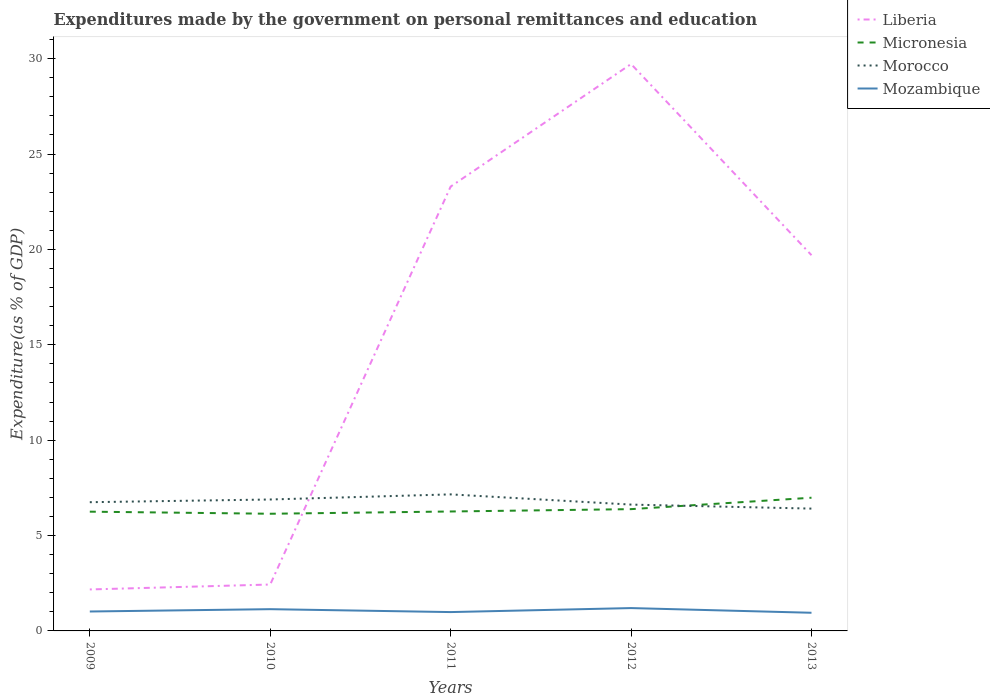Across all years, what is the maximum expenditures made by the government on personal remittances and education in Morocco?
Your answer should be compact. 6.41. In which year was the expenditures made by the government on personal remittances and education in Mozambique maximum?
Your response must be concise. 2013. What is the total expenditures made by the government on personal remittances and education in Micronesia in the graph?
Your answer should be compact. -0.73. What is the difference between the highest and the second highest expenditures made by the government on personal remittances and education in Mozambique?
Your answer should be compact. 0.25. What is the difference between the highest and the lowest expenditures made by the government on personal remittances and education in Morocco?
Give a very brief answer. 2. Does the graph contain any zero values?
Provide a succinct answer. No. Where does the legend appear in the graph?
Offer a very short reply. Top right. What is the title of the graph?
Give a very brief answer. Expenditures made by the government on personal remittances and education. What is the label or title of the X-axis?
Give a very brief answer. Years. What is the label or title of the Y-axis?
Your response must be concise. Expenditure(as % of GDP). What is the Expenditure(as % of GDP) in Liberia in 2009?
Your answer should be very brief. 2.17. What is the Expenditure(as % of GDP) of Micronesia in 2009?
Give a very brief answer. 6.25. What is the Expenditure(as % of GDP) in Morocco in 2009?
Provide a succinct answer. 6.75. What is the Expenditure(as % of GDP) of Mozambique in 2009?
Give a very brief answer. 1.02. What is the Expenditure(as % of GDP) of Liberia in 2010?
Your answer should be very brief. 2.43. What is the Expenditure(as % of GDP) in Micronesia in 2010?
Keep it short and to the point. 6.14. What is the Expenditure(as % of GDP) of Morocco in 2010?
Keep it short and to the point. 6.89. What is the Expenditure(as % of GDP) of Mozambique in 2010?
Offer a very short reply. 1.14. What is the Expenditure(as % of GDP) in Liberia in 2011?
Your answer should be compact. 23.29. What is the Expenditure(as % of GDP) of Micronesia in 2011?
Provide a short and direct response. 6.26. What is the Expenditure(as % of GDP) of Morocco in 2011?
Make the answer very short. 7.16. What is the Expenditure(as % of GDP) in Mozambique in 2011?
Ensure brevity in your answer.  0.99. What is the Expenditure(as % of GDP) of Liberia in 2012?
Your response must be concise. 29.72. What is the Expenditure(as % of GDP) of Micronesia in 2012?
Offer a terse response. 6.38. What is the Expenditure(as % of GDP) in Morocco in 2012?
Provide a short and direct response. 6.62. What is the Expenditure(as % of GDP) in Mozambique in 2012?
Offer a very short reply. 1.2. What is the Expenditure(as % of GDP) of Liberia in 2013?
Keep it short and to the point. 19.7. What is the Expenditure(as % of GDP) of Micronesia in 2013?
Offer a very short reply. 6.98. What is the Expenditure(as % of GDP) in Morocco in 2013?
Offer a very short reply. 6.41. What is the Expenditure(as % of GDP) of Mozambique in 2013?
Make the answer very short. 0.95. Across all years, what is the maximum Expenditure(as % of GDP) in Liberia?
Provide a succinct answer. 29.72. Across all years, what is the maximum Expenditure(as % of GDP) of Micronesia?
Ensure brevity in your answer.  6.98. Across all years, what is the maximum Expenditure(as % of GDP) of Morocco?
Offer a very short reply. 7.16. Across all years, what is the maximum Expenditure(as % of GDP) in Mozambique?
Your response must be concise. 1.2. Across all years, what is the minimum Expenditure(as % of GDP) of Liberia?
Offer a terse response. 2.17. Across all years, what is the minimum Expenditure(as % of GDP) of Micronesia?
Your response must be concise. 6.14. Across all years, what is the minimum Expenditure(as % of GDP) of Morocco?
Provide a succinct answer. 6.41. Across all years, what is the minimum Expenditure(as % of GDP) in Mozambique?
Your answer should be compact. 0.95. What is the total Expenditure(as % of GDP) in Liberia in the graph?
Your response must be concise. 77.32. What is the total Expenditure(as % of GDP) in Micronesia in the graph?
Provide a short and direct response. 32.02. What is the total Expenditure(as % of GDP) of Morocco in the graph?
Offer a terse response. 33.83. What is the total Expenditure(as % of GDP) in Mozambique in the graph?
Provide a succinct answer. 5.3. What is the difference between the Expenditure(as % of GDP) of Liberia in 2009 and that in 2010?
Offer a very short reply. -0.26. What is the difference between the Expenditure(as % of GDP) in Micronesia in 2009 and that in 2010?
Ensure brevity in your answer.  0.11. What is the difference between the Expenditure(as % of GDP) in Morocco in 2009 and that in 2010?
Give a very brief answer. -0.14. What is the difference between the Expenditure(as % of GDP) in Mozambique in 2009 and that in 2010?
Give a very brief answer. -0.12. What is the difference between the Expenditure(as % of GDP) in Liberia in 2009 and that in 2011?
Your response must be concise. -21.12. What is the difference between the Expenditure(as % of GDP) of Micronesia in 2009 and that in 2011?
Make the answer very short. -0.01. What is the difference between the Expenditure(as % of GDP) of Morocco in 2009 and that in 2011?
Give a very brief answer. -0.41. What is the difference between the Expenditure(as % of GDP) in Mozambique in 2009 and that in 2011?
Give a very brief answer. 0.03. What is the difference between the Expenditure(as % of GDP) in Liberia in 2009 and that in 2012?
Your answer should be compact. -27.55. What is the difference between the Expenditure(as % of GDP) in Micronesia in 2009 and that in 2012?
Offer a terse response. -0.13. What is the difference between the Expenditure(as % of GDP) of Morocco in 2009 and that in 2012?
Make the answer very short. 0.13. What is the difference between the Expenditure(as % of GDP) in Mozambique in 2009 and that in 2012?
Ensure brevity in your answer.  -0.18. What is the difference between the Expenditure(as % of GDP) in Liberia in 2009 and that in 2013?
Give a very brief answer. -17.52. What is the difference between the Expenditure(as % of GDP) of Micronesia in 2009 and that in 2013?
Keep it short and to the point. -0.73. What is the difference between the Expenditure(as % of GDP) in Morocco in 2009 and that in 2013?
Your answer should be compact. 0.34. What is the difference between the Expenditure(as % of GDP) of Mozambique in 2009 and that in 2013?
Your response must be concise. 0.07. What is the difference between the Expenditure(as % of GDP) of Liberia in 2010 and that in 2011?
Provide a succinct answer. -20.86. What is the difference between the Expenditure(as % of GDP) in Micronesia in 2010 and that in 2011?
Your answer should be very brief. -0.12. What is the difference between the Expenditure(as % of GDP) in Morocco in 2010 and that in 2011?
Offer a terse response. -0.27. What is the difference between the Expenditure(as % of GDP) in Mozambique in 2010 and that in 2011?
Offer a very short reply. 0.15. What is the difference between the Expenditure(as % of GDP) of Liberia in 2010 and that in 2012?
Provide a succinct answer. -27.29. What is the difference between the Expenditure(as % of GDP) in Micronesia in 2010 and that in 2012?
Offer a terse response. -0.24. What is the difference between the Expenditure(as % of GDP) in Morocco in 2010 and that in 2012?
Give a very brief answer. 0.27. What is the difference between the Expenditure(as % of GDP) in Mozambique in 2010 and that in 2012?
Keep it short and to the point. -0.06. What is the difference between the Expenditure(as % of GDP) in Liberia in 2010 and that in 2013?
Your answer should be compact. -17.27. What is the difference between the Expenditure(as % of GDP) of Micronesia in 2010 and that in 2013?
Your response must be concise. -0.84. What is the difference between the Expenditure(as % of GDP) of Morocco in 2010 and that in 2013?
Give a very brief answer. 0.48. What is the difference between the Expenditure(as % of GDP) in Mozambique in 2010 and that in 2013?
Your answer should be compact. 0.19. What is the difference between the Expenditure(as % of GDP) in Liberia in 2011 and that in 2012?
Your answer should be compact. -6.43. What is the difference between the Expenditure(as % of GDP) in Micronesia in 2011 and that in 2012?
Offer a very short reply. -0.12. What is the difference between the Expenditure(as % of GDP) in Morocco in 2011 and that in 2012?
Offer a very short reply. 0.54. What is the difference between the Expenditure(as % of GDP) in Mozambique in 2011 and that in 2012?
Keep it short and to the point. -0.21. What is the difference between the Expenditure(as % of GDP) of Liberia in 2011 and that in 2013?
Offer a terse response. 3.6. What is the difference between the Expenditure(as % of GDP) of Micronesia in 2011 and that in 2013?
Your response must be concise. -0.72. What is the difference between the Expenditure(as % of GDP) of Morocco in 2011 and that in 2013?
Ensure brevity in your answer.  0.75. What is the difference between the Expenditure(as % of GDP) of Mozambique in 2011 and that in 2013?
Offer a very short reply. 0.04. What is the difference between the Expenditure(as % of GDP) of Liberia in 2012 and that in 2013?
Offer a very short reply. 10.02. What is the difference between the Expenditure(as % of GDP) in Micronesia in 2012 and that in 2013?
Your answer should be very brief. -0.6. What is the difference between the Expenditure(as % of GDP) of Morocco in 2012 and that in 2013?
Your response must be concise. 0.21. What is the difference between the Expenditure(as % of GDP) of Mozambique in 2012 and that in 2013?
Offer a very short reply. 0.25. What is the difference between the Expenditure(as % of GDP) in Liberia in 2009 and the Expenditure(as % of GDP) in Micronesia in 2010?
Offer a terse response. -3.97. What is the difference between the Expenditure(as % of GDP) in Liberia in 2009 and the Expenditure(as % of GDP) in Morocco in 2010?
Give a very brief answer. -4.72. What is the difference between the Expenditure(as % of GDP) in Liberia in 2009 and the Expenditure(as % of GDP) in Mozambique in 2010?
Offer a terse response. 1.03. What is the difference between the Expenditure(as % of GDP) of Micronesia in 2009 and the Expenditure(as % of GDP) of Morocco in 2010?
Provide a short and direct response. -0.64. What is the difference between the Expenditure(as % of GDP) of Micronesia in 2009 and the Expenditure(as % of GDP) of Mozambique in 2010?
Keep it short and to the point. 5.11. What is the difference between the Expenditure(as % of GDP) in Morocco in 2009 and the Expenditure(as % of GDP) in Mozambique in 2010?
Your answer should be very brief. 5.61. What is the difference between the Expenditure(as % of GDP) in Liberia in 2009 and the Expenditure(as % of GDP) in Micronesia in 2011?
Ensure brevity in your answer.  -4.09. What is the difference between the Expenditure(as % of GDP) in Liberia in 2009 and the Expenditure(as % of GDP) in Morocco in 2011?
Offer a very short reply. -4.98. What is the difference between the Expenditure(as % of GDP) of Liberia in 2009 and the Expenditure(as % of GDP) of Mozambique in 2011?
Ensure brevity in your answer.  1.19. What is the difference between the Expenditure(as % of GDP) in Micronesia in 2009 and the Expenditure(as % of GDP) in Morocco in 2011?
Provide a succinct answer. -0.91. What is the difference between the Expenditure(as % of GDP) in Micronesia in 2009 and the Expenditure(as % of GDP) in Mozambique in 2011?
Your response must be concise. 5.26. What is the difference between the Expenditure(as % of GDP) of Morocco in 2009 and the Expenditure(as % of GDP) of Mozambique in 2011?
Offer a very short reply. 5.76. What is the difference between the Expenditure(as % of GDP) in Liberia in 2009 and the Expenditure(as % of GDP) in Micronesia in 2012?
Offer a terse response. -4.21. What is the difference between the Expenditure(as % of GDP) of Liberia in 2009 and the Expenditure(as % of GDP) of Morocco in 2012?
Keep it short and to the point. -4.45. What is the difference between the Expenditure(as % of GDP) of Liberia in 2009 and the Expenditure(as % of GDP) of Mozambique in 2012?
Your answer should be very brief. 0.98. What is the difference between the Expenditure(as % of GDP) in Micronesia in 2009 and the Expenditure(as % of GDP) in Morocco in 2012?
Keep it short and to the point. -0.37. What is the difference between the Expenditure(as % of GDP) of Micronesia in 2009 and the Expenditure(as % of GDP) of Mozambique in 2012?
Offer a very short reply. 5.05. What is the difference between the Expenditure(as % of GDP) of Morocco in 2009 and the Expenditure(as % of GDP) of Mozambique in 2012?
Your response must be concise. 5.55. What is the difference between the Expenditure(as % of GDP) of Liberia in 2009 and the Expenditure(as % of GDP) of Micronesia in 2013?
Your answer should be very brief. -4.81. What is the difference between the Expenditure(as % of GDP) of Liberia in 2009 and the Expenditure(as % of GDP) of Morocco in 2013?
Keep it short and to the point. -4.24. What is the difference between the Expenditure(as % of GDP) of Liberia in 2009 and the Expenditure(as % of GDP) of Mozambique in 2013?
Make the answer very short. 1.22. What is the difference between the Expenditure(as % of GDP) in Micronesia in 2009 and the Expenditure(as % of GDP) in Morocco in 2013?
Your answer should be compact. -0.16. What is the difference between the Expenditure(as % of GDP) in Micronesia in 2009 and the Expenditure(as % of GDP) in Mozambique in 2013?
Provide a short and direct response. 5.3. What is the difference between the Expenditure(as % of GDP) of Morocco in 2009 and the Expenditure(as % of GDP) of Mozambique in 2013?
Make the answer very short. 5.8. What is the difference between the Expenditure(as % of GDP) in Liberia in 2010 and the Expenditure(as % of GDP) in Micronesia in 2011?
Your answer should be very brief. -3.83. What is the difference between the Expenditure(as % of GDP) of Liberia in 2010 and the Expenditure(as % of GDP) of Morocco in 2011?
Your response must be concise. -4.73. What is the difference between the Expenditure(as % of GDP) of Liberia in 2010 and the Expenditure(as % of GDP) of Mozambique in 2011?
Provide a succinct answer. 1.44. What is the difference between the Expenditure(as % of GDP) in Micronesia in 2010 and the Expenditure(as % of GDP) in Morocco in 2011?
Provide a succinct answer. -1.02. What is the difference between the Expenditure(as % of GDP) of Micronesia in 2010 and the Expenditure(as % of GDP) of Mozambique in 2011?
Your answer should be very brief. 5.16. What is the difference between the Expenditure(as % of GDP) in Morocco in 2010 and the Expenditure(as % of GDP) in Mozambique in 2011?
Offer a very short reply. 5.9. What is the difference between the Expenditure(as % of GDP) of Liberia in 2010 and the Expenditure(as % of GDP) of Micronesia in 2012?
Provide a succinct answer. -3.95. What is the difference between the Expenditure(as % of GDP) in Liberia in 2010 and the Expenditure(as % of GDP) in Morocco in 2012?
Keep it short and to the point. -4.19. What is the difference between the Expenditure(as % of GDP) of Liberia in 2010 and the Expenditure(as % of GDP) of Mozambique in 2012?
Provide a succinct answer. 1.23. What is the difference between the Expenditure(as % of GDP) of Micronesia in 2010 and the Expenditure(as % of GDP) of Morocco in 2012?
Give a very brief answer. -0.48. What is the difference between the Expenditure(as % of GDP) of Micronesia in 2010 and the Expenditure(as % of GDP) of Mozambique in 2012?
Your answer should be compact. 4.94. What is the difference between the Expenditure(as % of GDP) of Morocco in 2010 and the Expenditure(as % of GDP) of Mozambique in 2012?
Your response must be concise. 5.69. What is the difference between the Expenditure(as % of GDP) of Liberia in 2010 and the Expenditure(as % of GDP) of Micronesia in 2013?
Provide a short and direct response. -4.55. What is the difference between the Expenditure(as % of GDP) in Liberia in 2010 and the Expenditure(as % of GDP) in Morocco in 2013?
Provide a succinct answer. -3.98. What is the difference between the Expenditure(as % of GDP) in Liberia in 2010 and the Expenditure(as % of GDP) in Mozambique in 2013?
Offer a terse response. 1.48. What is the difference between the Expenditure(as % of GDP) in Micronesia in 2010 and the Expenditure(as % of GDP) in Morocco in 2013?
Make the answer very short. -0.27. What is the difference between the Expenditure(as % of GDP) in Micronesia in 2010 and the Expenditure(as % of GDP) in Mozambique in 2013?
Your answer should be compact. 5.19. What is the difference between the Expenditure(as % of GDP) of Morocco in 2010 and the Expenditure(as % of GDP) of Mozambique in 2013?
Offer a very short reply. 5.94. What is the difference between the Expenditure(as % of GDP) in Liberia in 2011 and the Expenditure(as % of GDP) in Micronesia in 2012?
Offer a terse response. 16.91. What is the difference between the Expenditure(as % of GDP) of Liberia in 2011 and the Expenditure(as % of GDP) of Morocco in 2012?
Your response must be concise. 16.67. What is the difference between the Expenditure(as % of GDP) in Liberia in 2011 and the Expenditure(as % of GDP) in Mozambique in 2012?
Provide a succinct answer. 22.1. What is the difference between the Expenditure(as % of GDP) of Micronesia in 2011 and the Expenditure(as % of GDP) of Morocco in 2012?
Your answer should be very brief. -0.36. What is the difference between the Expenditure(as % of GDP) of Micronesia in 2011 and the Expenditure(as % of GDP) of Mozambique in 2012?
Offer a very short reply. 5.06. What is the difference between the Expenditure(as % of GDP) in Morocco in 2011 and the Expenditure(as % of GDP) in Mozambique in 2012?
Keep it short and to the point. 5.96. What is the difference between the Expenditure(as % of GDP) of Liberia in 2011 and the Expenditure(as % of GDP) of Micronesia in 2013?
Provide a short and direct response. 16.31. What is the difference between the Expenditure(as % of GDP) of Liberia in 2011 and the Expenditure(as % of GDP) of Morocco in 2013?
Provide a succinct answer. 16.88. What is the difference between the Expenditure(as % of GDP) of Liberia in 2011 and the Expenditure(as % of GDP) of Mozambique in 2013?
Provide a succinct answer. 22.34. What is the difference between the Expenditure(as % of GDP) in Micronesia in 2011 and the Expenditure(as % of GDP) in Morocco in 2013?
Provide a short and direct response. -0.15. What is the difference between the Expenditure(as % of GDP) of Micronesia in 2011 and the Expenditure(as % of GDP) of Mozambique in 2013?
Keep it short and to the point. 5.31. What is the difference between the Expenditure(as % of GDP) in Morocco in 2011 and the Expenditure(as % of GDP) in Mozambique in 2013?
Your response must be concise. 6.21. What is the difference between the Expenditure(as % of GDP) in Liberia in 2012 and the Expenditure(as % of GDP) in Micronesia in 2013?
Your answer should be compact. 22.74. What is the difference between the Expenditure(as % of GDP) in Liberia in 2012 and the Expenditure(as % of GDP) in Morocco in 2013?
Make the answer very short. 23.31. What is the difference between the Expenditure(as % of GDP) of Liberia in 2012 and the Expenditure(as % of GDP) of Mozambique in 2013?
Ensure brevity in your answer.  28.77. What is the difference between the Expenditure(as % of GDP) of Micronesia in 2012 and the Expenditure(as % of GDP) of Morocco in 2013?
Your response must be concise. -0.03. What is the difference between the Expenditure(as % of GDP) of Micronesia in 2012 and the Expenditure(as % of GDP) of Mozambique in 2013?
Keep it short and to the point. 5.43. What is the difference between the Expenditure(as % of GDP) in Morocco in 2012 and the Expenditure(as % of GDP) in Mozambique in 2013?
Your answer should be compact. 5.67. What is the average Expenditure(as % of GDP) in Liberia per year?
Provide a short and direct response. 15.46. What is the average Expenditure(as % of GDP) of Micronesia per year?
Your response must be concise. 6.4. What is the average Expenditure(as % of GDP) of Morocco per year?
Make the answer very short. 6.77. What is the average Expenditure(as % of GDP) in Mozambique per year?
Ensure brevity in your answer.  1.06. In the year 2009, what is the difference between the Expenditure(as % of GDP) of Liberia and Expenditure(as % of GDP) of Micronesia?
Your answer should be compact. -4.08. In the year 2009, what is the difference between the Expenditure(as % of GDP) of Liberia and Expenditure(as % of GDP) of Morocco?
Provide a succinct answer. -4.57. In the year 2009, what is the difference between the Expenditure(as % of GDP) of Liberia and Expenditure(as % of GDP) of Mozambique?
Provide a succinct answer. 1.16. In the year 2009, what is the difference between the Expenditure(as % of GDP) of Micronesia and Expenditure(as % of GDP) of Morocco?
Your answer should be very brief. -0.5. In the year 2009, what is the difference between the Expenditure(as % of GDP) of Micronesia and Expenditure(as % of GDP) of Mozambique?
Your answer should be very brief. 5.23. In the year 2009, what is the difference between the Expenditure(as % of GDP) of Morocco and Expenditure(as % of GDP) of Mozambique?
Your answer should be compact. 5.73. In the year 2010, what is the difference between the Expenditure(as % of GDP) in Liberia and Expenditure(as % of GDP) in Micronesia?
Keep it short and to the point. -3.71. In the year 2010, what is the difference between the Expenditure(as % of GDP) of Liberia and Expenditure(as % of GDP) of Morocco?
Your answer should be very brief. -4.46. In the year 2010, what is the difference between the Expenditure(as % of GDP) in Liberia and Expenditure(as % of GDP) in Mozambique?
Offer a terse response. 1.29. In the year 2010, what is the difference between the Expenditure(as % of GDP) in Micronesia and Expenditure(as % of GDP) in Morocco?
Keep it short and to the point. -0.75. In the year 2010, what is the difference between the Expenditure(as % of GDP) of Micronesia and Expenditure(as % of GDP) of Mozambique?
Offer a very short reply. 5. In the year 2010, what is the difference between the Expenditure(as % of GDP) of Morocco and Expenditure(as % of GDP) of Mozambique?
Provide a short and direct response. 5.75. In the year 2011, what is the difference between the Expenditure(as % of GDP) of Liberia and Expenditure(as % of GDP) of Micronesia?
Offer a terse response. 17.03. In the year 2011, what is the difference between the Expenditure(as % of GDP) in Liberia and Expenditure(as % of GDP) in Morocco?
Your response must be concise. 16.14. In the year 2011, what is the difference between the Expenditure(as % of GDP) in Liberia and Expenditure(as % of GDP) in Mozambique?
Offer a terse response. 22.31. In the year 2011, what is the difference between the Expenditure(as % of GDP) in Micronesia and Expenditure(as % of GDP) in Morocco?
Give a very brief answer. -0.9. In the year 2011, what is the difference between the Expenditure(as % of GDP) in Micronesia and Expenditure(as % of GDP) in Mozambique?
Ensure brevity in your answer.  5.27. In the year 2011, what is the difference between the Expenditure(as % of GDP) of Morocco and Expenditure(as % of GDP) of Mozambique?
Offer a terse response. 6.17. In the year 2012, what is the difference between the Expenditure(as % of GDP) of Liberia and Expenditure(as % of GDP) of Micronesia?
Offer a terse response. 23.34. In the year 2012, what is the difference between the Expenditure(as % of GDP) in Liberia and Expenditure(as % of GDP) in Morocco?
Provide a succinct answer. 23.1. In the year 2012, what is the difference between the Expenditure(as % of GDP) in Liberia and Expenditure(as % of GDP) in Mozambique?
Keep it short and to the point. 28.52. In the year 2012, what is the difference between the Expenditure(as % of GDP) in Micronesia and Expenditure(as % of GDP) in Morocco?
Make the answer very short. -0.24. In the year 2012, what is the difference between the Expenditure(as % of GDP) in Micronesia and Expenditure(as % of GDP) in Mozambique?
Your response must be concise. 5.19. In the year 2012, what is the difference between the Expenditure(as % of GDP) of Morocco and Expenditure(as % of GDP) of Mozambique?
Make the answer very short. 5.42. In the year 2013, what is the difference between the Expenditure(as % of GDP) in Liberia and Expenditure(as % of GDP) in Micronesia?
Offer a very short reply. 12.71. In the year 2013, what is the difference between the Expenditure(as % of GDP) of Liberia and Expenditure(as % of GDP) of Morocco?
Offer a terse response. 13.29. In the year 2013, what is the difference between the Expenditure(as % of GDP) in Liberia and Expenditure(as % of GDP) in Mozambique?
Provide a succinct answer. 18.75. In the year 2013, what is the difference between the Expenditure(as % of GDP) of Micronesia and Expenditure(as % of GDP) of Morocco?
Give a very brief answer. 0.57. In the year 2013, what is the difference between the Expenditure(as % of GDP) in Micronesia and Expenditure(as % of GDP) in Mozambique?
Keep it short and to the point. 6.03. In the year 2013, what is the difference between the Expenditure(as % of GDP) in Morocco and Expenditure(as % of GDP) in Mozambique?
Give a very brief answer. 5.46. What is the ratio of the Expenditure(as % of GDP) of Liberia in 2009 to that in 2010?
Your answer should be compact. 0.89. What is the ratio of the Expenditure(as % of GDP) of Micronesia in 2009 to that in 2010?
Your answer should be compact. 1.02. What is the ratio of the Expenditure(as % of GDP) of Morocco in 2009 to that in 2010?
Provide a short and direct response. 0.98. What is the ratio of the Expenditure(as % of GDP) in Mozambique in 2009 to that in 2010?
Ensure brevity in your answer.  0.89. What is the ratio of the Expenditure(as % of GDP) in Liberia in 2009 to that in 2011?
Keep it short and to the point. 0.09. What is the ratio of the Expenditure(as % of GDP) in Micronesia in 2009 to that in 2011?
Give a very brief answer. 1. What is the ratio of the Expenditure(as % of GDP) of Morocco in 2009 to that in 2011?
Make the answer very short. 0.94. What is the ratio of the Expenditure(as % of GDP) in Mozambique in 2009 to that in 2011?
Offer a very short reply. 1.03. What is the ratio of the Expenditure(as % of GDP) in Liberia in 2009 to that in 2012?
Provide a succinct answer. 0.07. What is the ratio of the Expenditure(as % of GDP) in Micronesia in 2009 to that in 2012?
Your answer should be very brief. 0.98. What is the ratio of the Expenditure(as % of GDP) of Mozambique in 2009 to that in 2012?
Make the answer very short. 0.85. What is the ratio of the Expenditure(as % of GDP) of Liberia in 2009 to that in 2013?
Offer a terse response. 0.11. What is the ratio of the Expenditure(as % of GDP) of Micronesia in 2009 to that in 2013?
Provide a succinct answer. 0.9. What is the ratio of the Expenditure(as % of GDP) of Morocco in 2009 to that in 2013?
Offer a terse response. 1.05. What is the ratio of the Expenditure(as % of GDP) of Mozambique in 2009 to that in 2013?
Provide a short and direct response. 1.07. What is the ratio of the Expenditure(as % of GDP) of Liberia in 2010 to that in 2011?
Give a very brief answer. 0.1. What is the ratio of the Expenditure(as % of GDP) in Micronesia in 2010 to that in 2011?
Offer a very short reply. 0.98. What is the ratio of the Expenditure(as % of GDP) in Morocco in 2010 to that in 2011?
Offer a very short reply. 0.96. What is the ratio of the Expenditure(as % of GDP) in Mozambique in 2010 to that in 2011?
Make the answer very short. 1.15. What is the ratio of the Expenditure(as % of GDP) of Liberia in 2010 to that in 2012?
Give a very brief answer. 0.08. What is the ratio of the Expenditure(as % of GDP) of Micronesia in 2010 to that in 2012?
Offer a very short reply. 0.96. What is the ratio of the Expenditure(as % of GDP) of Morocco in 2010 to that in 2012?
Keep it short and to the point. 1.04. What is the ratio of the Expenditure(as % of GDP) in Mozambique in 2010 to that in 2012?
Make the answer very short. 0.95. What is the ratio of the Expenditure(as % of GDP) of Liberia in 2010 to that in 2013?
Ensure brevity in your answer.  0.12. What is the ratio of the Expenditure(as % of GDP) of Micronesia in 2010 to that in 2013?
Provide a succinct answer. 0.88. What is the ratio of the Expenditure(as % of GDP) in Morocco in 2010 to that in 2013?
Your answer should be very brief. 1.07. What is the ratio of the Expenditure(as % of GDP) of Mozambique in 2010 to that in 2013?
Offer a terse response. 1.2. What is the ratio of the Expenditure(as % of GDP) in Liberia in 2011 to that in 2012?
Offer a terse response. 0.78. What is the ratio of the Expenditure(as % of GDP) of Micronesia in 2011 to that in 2012?
Offer a very short reply. 0.98. What is the ratio of the Expenditure(as % of GDP) of Morocco in 2011 to that in 2012?
Your answer should be very brief. 1.08. What is the ratio of the Expenditure(as % of GDP) in Mozambique in 2011 to that in 2012?
Provide a short and direct response. 0.82. What is the ratio of the Expenditure(as % of GDP) in Liberia in 2011 to that in 2013?
Provide a short and direct response. 1.18. What is the ratio of the Expenditure(as % of GDP) in Micronesia in 2011 to that in 2013?
Offer a terse response. 0.9. What is the ratio of the Expenditure(as % of GDP) in Morocco in 2011 to that in 2013?
Make the answer very short. 1.12. What is the ratio of the Expenditure(as % of GDP) of Mozambique in 2011 to that in 2013?
Offer a terse response. 1.04. What is the ratio of the Expenditure(as % of GDP) of Liberia in 2012 to that in 2013?
Your response must be concise. 1.51. What is the ratio of the Expenditure(as % of GDP) of Micronesia in 2012 to that in 2013?
Offer a terse response. 0.91. What is the ratio of the Expenditure(as % of GDP) of Morocco in 2012 to that in 2013?
Make the answer very short. 1.03. What is the ratio of the Expenditure(as % of GDP) in Mozambique in 2012 to that in 2013?
Ensure brevity in your answer.  1.26. What is the difference between the highest and the second highest Expenditure(as % of GDP) in Liberia?
Offer a very short reply. 6.43. What is the difference between the highest and the second highest Expenditure(as % of GDP) in Micronesia?
Keep it short and to the point. 0.6. What is the difference between the highest and the second highest Expenditure(as % of GDP) in Morocco?
Your response must be concise. 0.27. What is the difference between the highest and the second highest Expenditure(as % of GDP) in Mozambique?
Your response must be concise. 0.06. What is the difference between the highest and the lowest Expenditure(as % of GDP) in Liberia?
Your answer should be compact. 27.55. What is the difference between the highest and the lowest Expenditure(as % of GDP) in Micronesia?
Offer a terse response. 0.84. What is the difference between the highest and the lowest Expenditure(as % of GDP) of Morocco?
Your answer should be very brief. 0.75. What is the difference between the highest and the lowest Expenditure(as % of GDP) of Mozambique?
Offer a terse response. 0.25. 